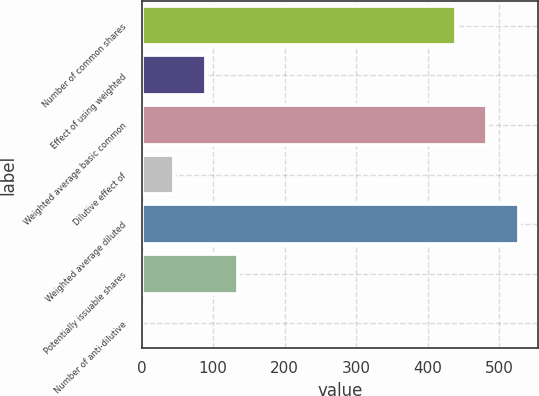Convert chart. <chart><loc_0><loc_0><loc_500><loc_500><bar_chart><fcel>Number of common shares<fcel>Effect of using weighted<fcel>Weighted average basic common<fcel>Dilutive effect of<fcel>Weighted average diluted<fcel>Potentially issuable shares<fcel>Number of anti-dilutive<nl><fcel>439.3<fcel>90.1<fcel>483.85<fcel>45.55<fcel>528.4<fcel>134.65<fcel>1<nl></chart> 